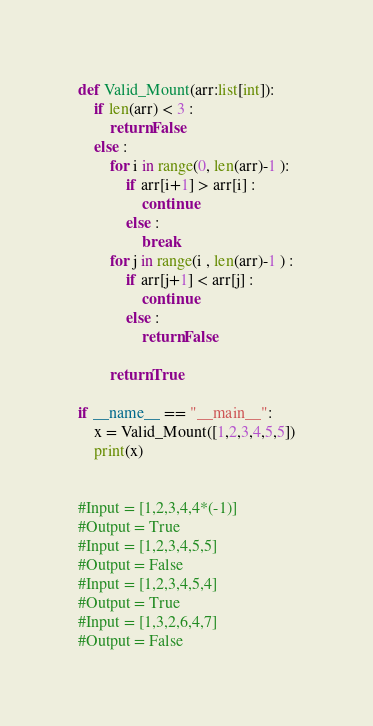<code> <loc_0><loc_0><loc_500><loc_500><_Python_>def Valid_Mount(arr:list[int]):
    if len(arr) < 3 :
        return False
    else :
        for i in range(0, len(arr)-1 ):
            if arr[i+1] > arr[i] :
                continue
            else :
                break
        for j in range(i , len(arr)-1 ) :
            if arr[j+1] < arr[j] :
                continue
            else :
                return False

        return True

if __name__ == "__main__":
    x = Valid_Mount([1,2,3,4,5,5])
    print(x)


#Input = [1,2,3,4,4*(-1)]
#Output = True
#Input = [1,2,3,4,5,5] 
#Output = False
#Input = [1,2,3,4,5,4]
#Output = True
#Input = [1,3,2,6,4,7]
#Output = False</code> 